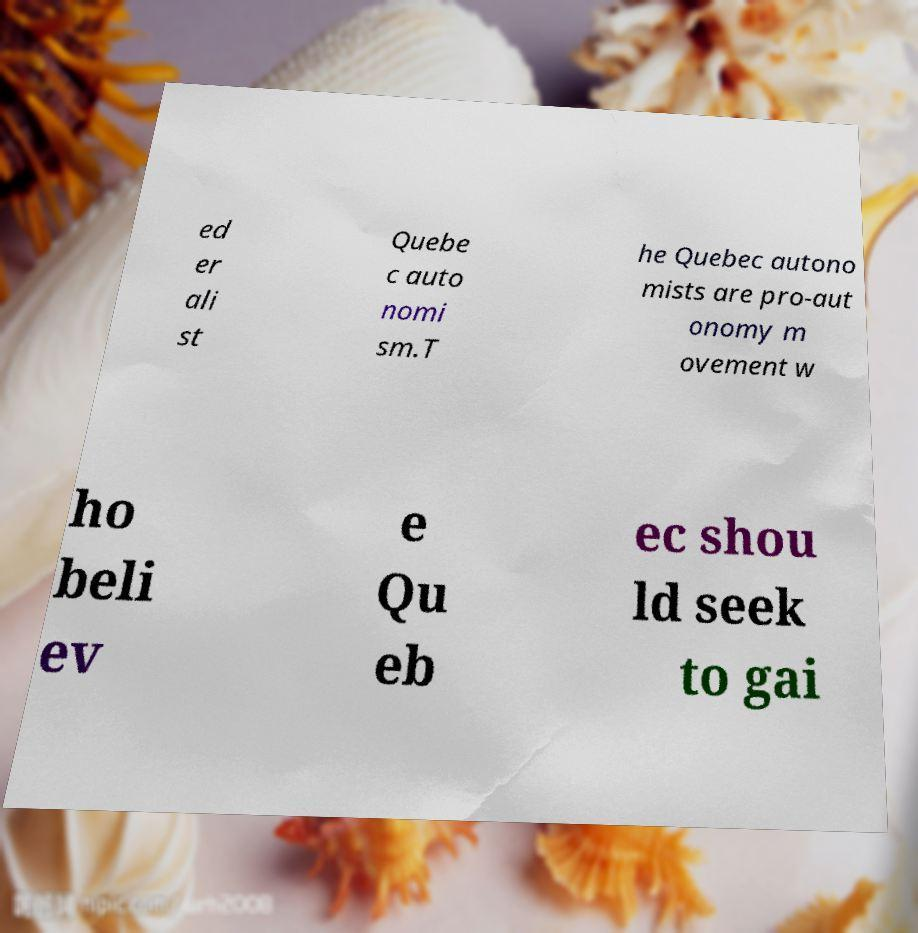For documentation purposes, I need the text within this image transcribed. Could you provide that? ed er ali st Quebe c auto nomi sm.T he Quebec autono mists are pro-aut onomy m ovement w ho beli ev e Qu eb ec shou ld seek to gai 